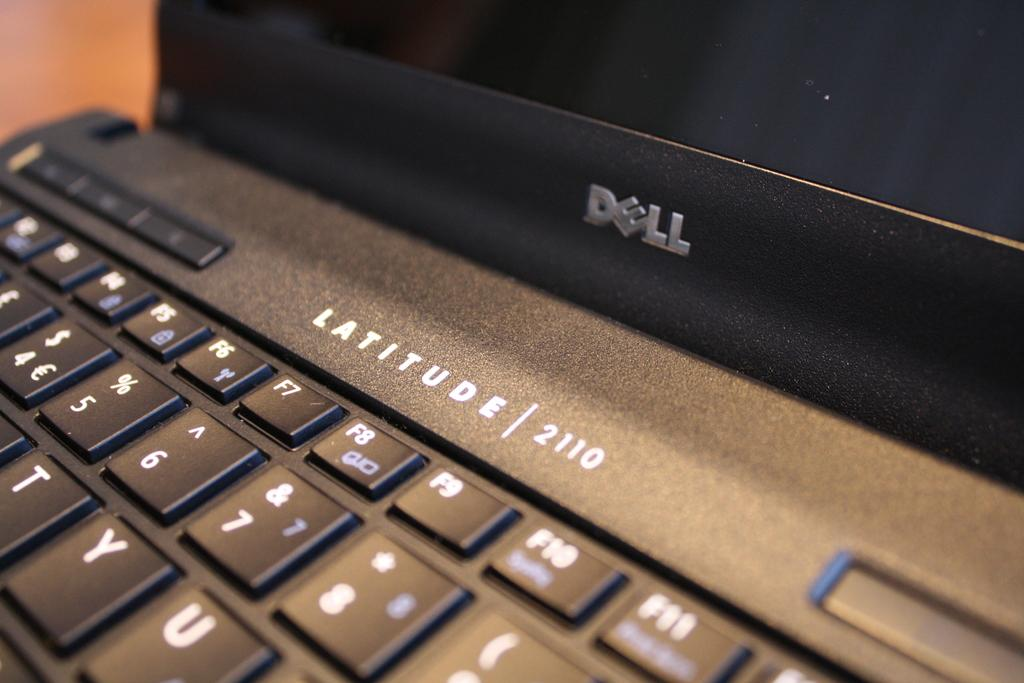<image>
Present a compact description of the photo's key features. A Dell laptop with Latitude 2110 printed on it. 